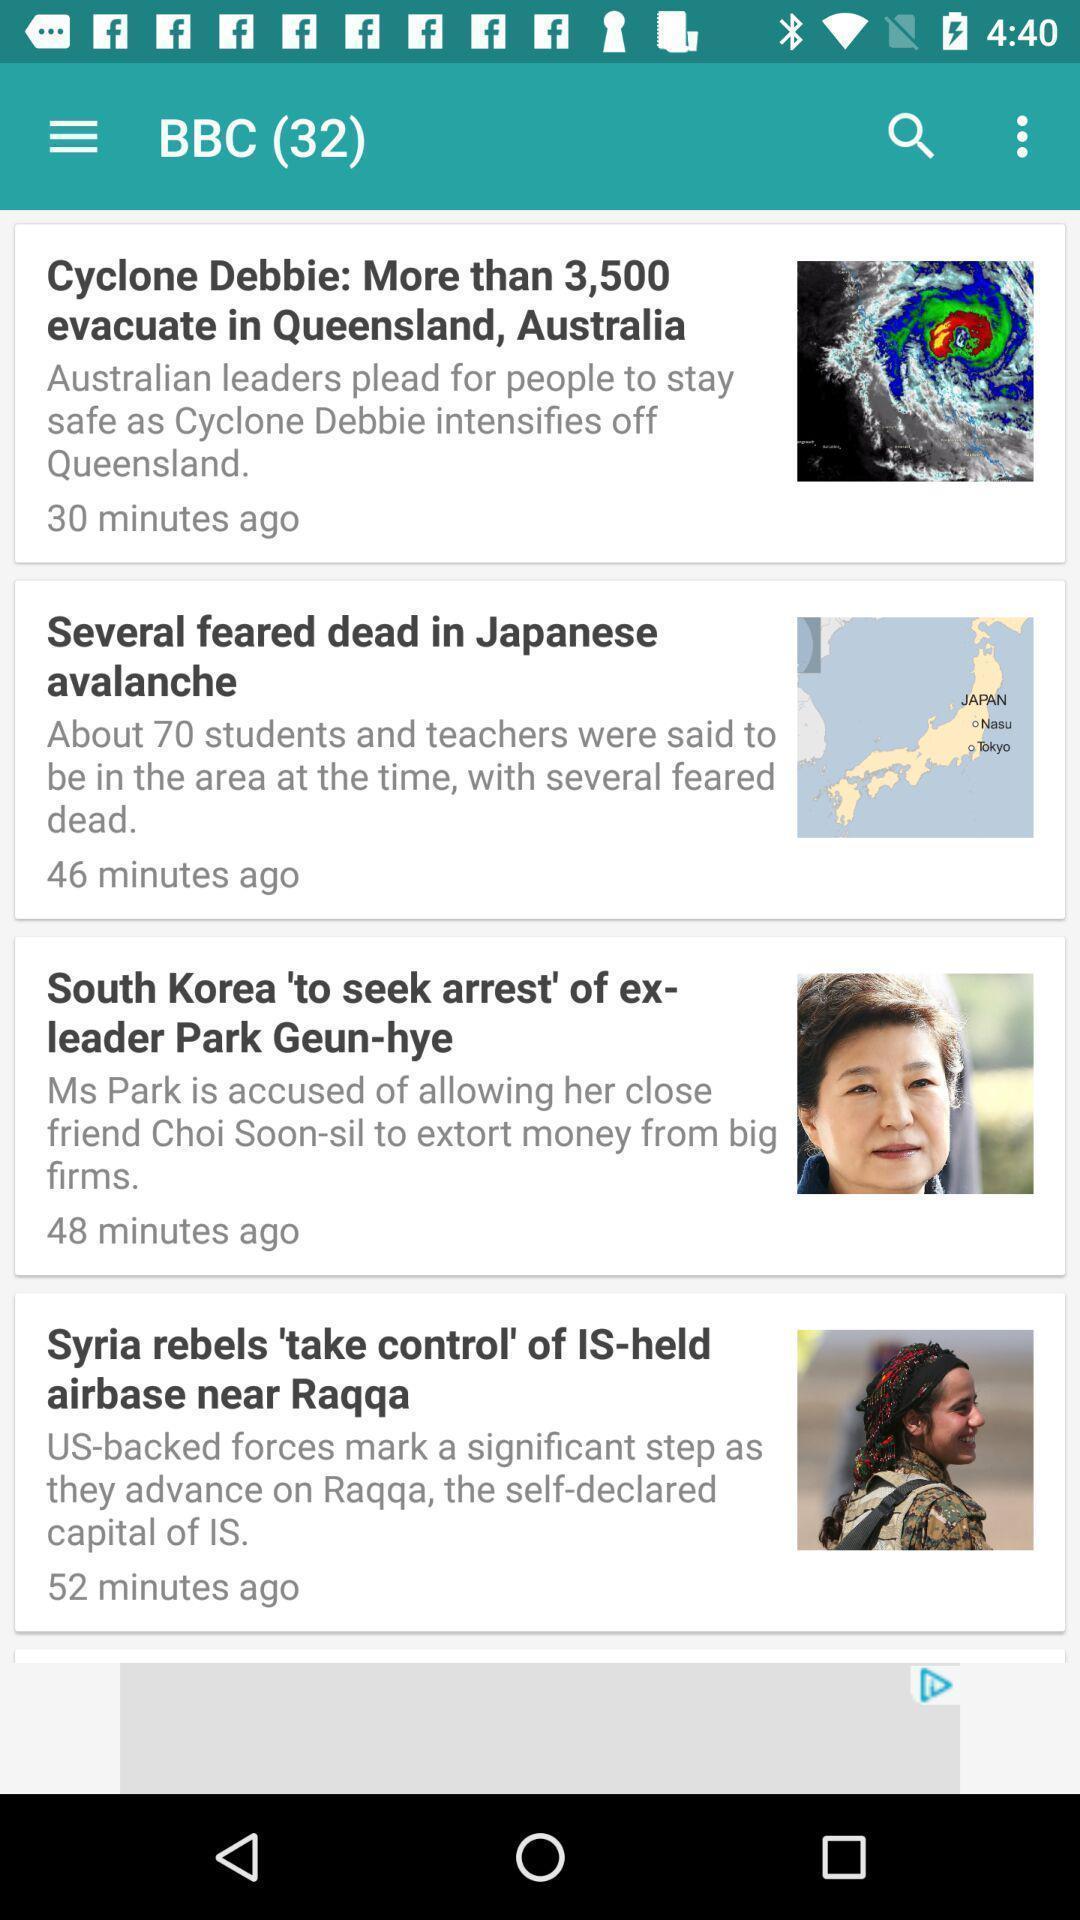Describe this image in words. Screen displaying multiple news articles information with time. 